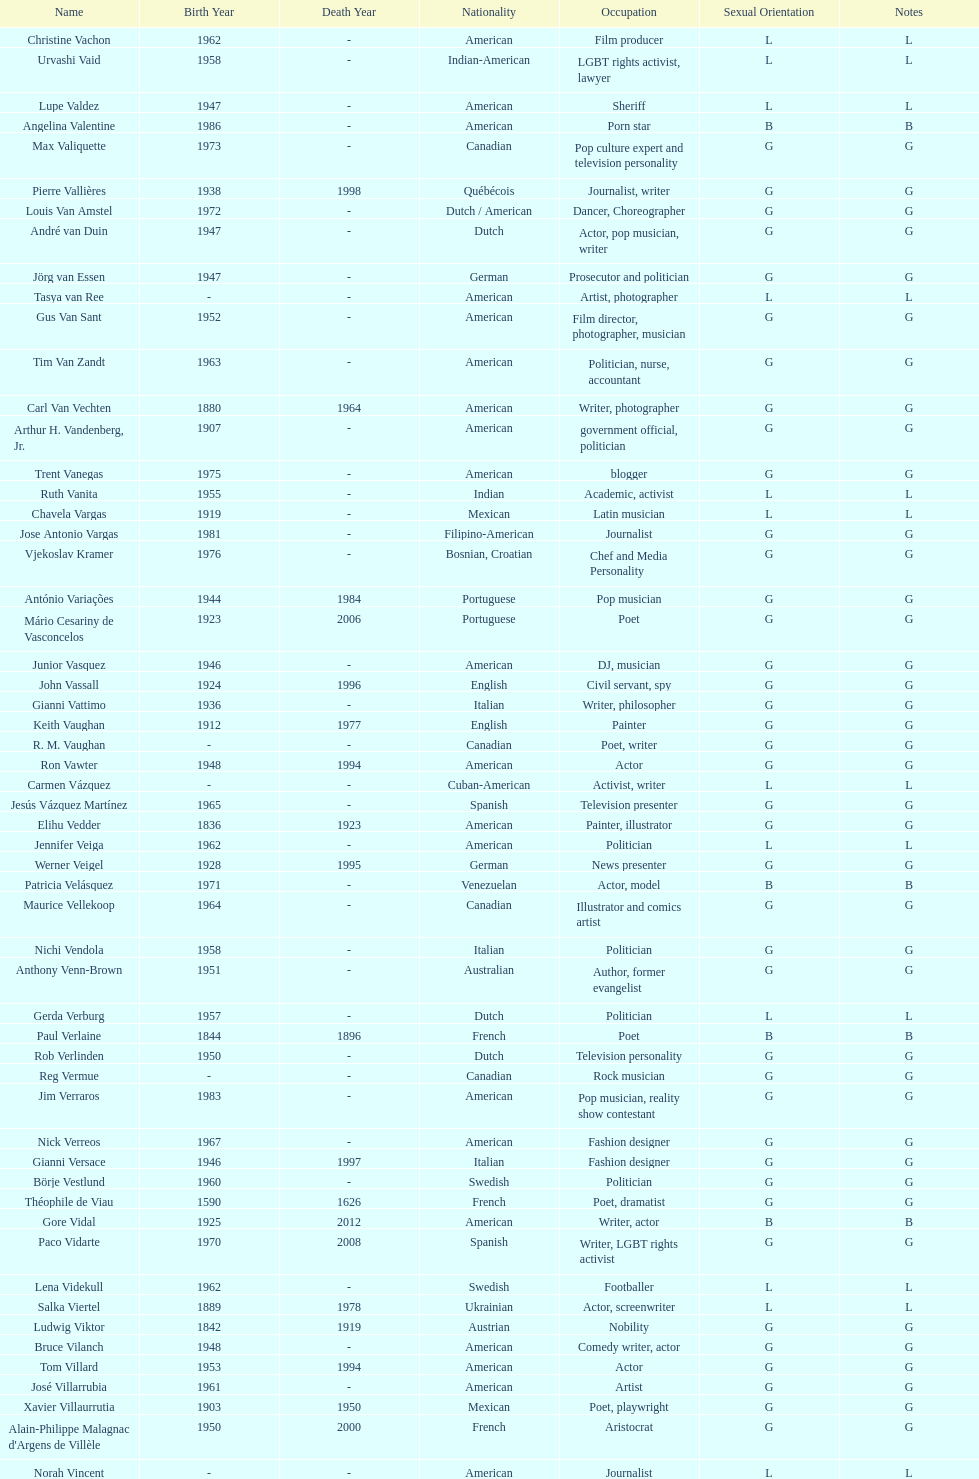Who lived longer, van vechten or variacoes? Van Vechten. Could you parse the entire table as a dict? {'header': ['Name', 'Birth Year', 'Death Year', 'Nationality', 'Occupation', 'Sexual Orientation', 'Notes'], 'rows': [['Christine Vachon', '1962', '-', 'American', 'Film producer', 'L', 'L'], ['Urvashi Vaid', '1958', '-', 'Indian-American', 'LGBT rights activist, lawyer', 'L', 'L'], ['Lupe Valdez', '1947', '-', 'American', 'Sheriff', 'L', 'L'], ['Angelina Valentine', '1986', '-', 'American', 'Porn star', 'B', 'B'], ['Max Valiquette', '1973', '-', 'Canadian', 'Pop culture expert and television personality', 'G', 'G'], ['Pierre Vallières', '1938', '1998', 'Québécois', 'Journalist, writer', 'G', 'G'], ['Louis Van Amstel', '1972', '-', 'Dutch / American', 'Dancer, Choreographer', 'G', 'G'], ['André van Duin', '1947', '-', 'Dutch', 'Actor, pop musician, writer', 'G', 'G'], ['Jörg van Essen', '1947', '-', 'German', 'Prosecutor and politician', 'G', 'G'], ['Tasya van Ree', '-', '-', 'American', 'Artist, photographer', 'L', 'L'], ['Gus Van Sant', '1952', '-', 'American', 'Film director, photographer, musician', 'G', 'G'], ['Tim Van Zandt', '1963', '-', 'American', 'Politician, nurse, accountant', 'G', 'G'], ['Carl Van Vechten', '1880', '1964', 'American', 'Writer, photographer', 'G', 'G'], ['Arthur H. Vandenberg, Jr.', '1907', '-', 'American', 'government official, politician', 'G', 'G'], ['Trent Vanegas', '1975', '-', 'American', 'blogger', 'G', 'G'], ['Ruth Vanita', '1955', '-', 'Indian', 'Academic, activist', 'L', 'L'], ['Chavela Vargas', '1919', '-', 'Mexican', 'Latin musician', 'L', 'L'], ['Jose Antonio Vargas', '1981', '-', 'Filipino-American', 'Journalist', 'G', 'G'], ['Vjekoslav Kramer', '1976', '-', 'Bosnian, Croatian', 'Chef and Media Personality', 'G', 'G'], ['António Variações', '1944', '1984', 'Portuguese', 'Pop musician', 'G', 'G'], ['Mário Cesariny de Vasconcelos', '1923', '2006', 'Portuguese', 'Poet', 'G', 'G'], ['Junior Vasquez', '1946', '-', 'American', 'DJ, musician', 'G', 'G'], ['John Vassall', '1924', '1996', 'English', 'Civil servant, spy', 'G', 'G'], ['Gianni Vattimo', '1936', '-', 'Italian', 'Writer, philosopher', 'G', 'G'], ['Keith Vaughan', '1912', '1977', 'English', 'Painter', 'G', 'G'], ['R. M. Vaughan', '-', '-', 'Canadian', 'Poet, writer', 'G', 'G'], ['Ron Vawter', '1948', '1994', 'American', 'Actor', 'G', 'G'], ['Carmen Vázquez', '-', '-', 'Cuban-American', 'Activist, writer', 'L', 'L'], ['Jesús Vázquez Martínez', '1965', '-', 'Spanish', 'Television presenter', 'G', 'G'], ['Elihu Vedder', '1836', '1923', 'American', 'Painter, illustrator', 'G', 'G'], ['Jennifer Veiga', '1962', '-', 'American', 'Politician', 'L', 'L'], ['Werner Veigel', '1928', '1995', 'German', 'News presenter', 'G', 'G'], ['Patricia Velásquez', '1971', '-', 'Venezuelan', 'Actor, model', 'B', 'B'], ['Maurice Vellekoop', '1964', '-', 'Canadian', 'Illustrator and comics artist', 'G', 'G'], ['Nichi Vendola', '1958', '-', 'Italian', 'Politician', 'G', 'G'], ['Anthony Venn-Brown', '1951', '-', 'Australian', 'Author, former evangelist', 'G', 'G'], ['Gerda Verburg', '1957', '-', 'Dutch', 'Politician', 'L', 'L'], ['Paul Verlaine', '1844', '1896', 'French', 'Poet', 'B', 'B'], ['Rob Verlinden', '1950', '-', 'Dutch', 'Television personality', 'G', 'G'], ['Reg Vermue', '-', '-', 'Canadian', 'Rock musician', 'G', 'G'], ['Jim Verraros', '1983', '-', 'American', 'Pop musician, reality show contestant', 'G', 'G'], ['Nick Verreos', '1967', '-', 'American', 'Fashion designer', 'G', 'G'], ['Gianni Versace', '1946', '1997', 'Italian', 'Fashion designer', 'G', 'G'], ['Börje Vestlund', '1960', '-', 'Swedish', 'Politician', 'G', 'G'], ['Théophile de Viau', '1590', '1626', 'French', 'Poet, dramatist', 'G', 'G'], ['Gore Vidal', '1925', '2012', 'American', 'Writer, actor', 'B', 'B'], ['Paco Vidarte', '1970', '2008', 'Spanish', 'Writer, LGBT rights activist', 'G', 'G'], ['Lena Videkull', '1962', '-', 'Swedish', 'Footballer', 'L', 'L'], ['Salka Viertel', '1889', '1978', 'Ukrainian', 'Actor, screenwriter', 'L', 'L'], ['Ludwig Viktor', '1842', '1919', 'Austrian', 'Nobility', 'G', 'G'], ['Bruce Vilanch', '1948', '-', 'American', 'Comedy writer, actor', 'G', 'G'], ['Tom Villard', '1953', '1994', 'American', 'Actor', 'G', 'G'], ['José Villarrubia', '1961', '-', 'American', 'Artist', 'G', 'G'], ['Xavier Villaurrutia', '1903', '1950', 'Mexican', 'Poet, playwright', 'G', 'G'], ["Alain-Philippe Malagnac d'Argens de Villèle", '1950', '2000', 'French', 'Aristocrat', 'G', 'G'], ['Norah Vincent', '-', '-', 'American', 'Journalist', 'L', 'L'], ['Donald Vining', '1917', '1998', 'American', 'Writer', 'G', 'G'], ['Luchino Visconti', '1906', '1976', 'Italian', 'Filmmaker', 'G', 'G'], ['Pavel Vítek', '1962', '-', 'Czech', 'Pop musician, actor', 'G', 'G'], ['Renée Vivien', '1877', '1909', 'English', 'Poet', 'L', 'L'], ['Claude Vivier', '1948', '1983', 'Canadian', '20th century classical composer', 'G', 'G'], ['Taylor Vixen', '1983', '-', 'American', 'Porn star', 'B', 'B'], ['Bruce Voeller', '1934', '1994', 'American', 'HIV/AIDS researcher', 'G', 'G'], ['Paula Vogel', '1951', '-', 'American', 'Playwright', 'L', 'L'], ['Julia Volkova', '1985', '-', 'Russian', 'Singer', 'B', 'B'], ['Jörg van Essen', '1947', '-', 'German', 'Politician', 'G', 'G'], ['Ole von Beust', '1955', '-', 'German', 'Politician', 'G', 'G'], ['Wilhelm von Gloeden', '1856', '1931', 'German', 'Photographer', 'G', 'G'], ['Rosa von Praunheim', '1942', '-', 'German', 'Film director', 'G', 'G'], ['Kurt von Ruffin', '1901', '1996', 'German', 'Holocaust survivor', 'G', 'G'], ['Hella von Sinnen', '1959', '-', 'German', 'Comedian', 'L', 'L'], ['Daniel Vosovic', '1981', '-', 'American', 'Fashion designer', 'G', 'G'], ['Delwin Vriend', '1966', '-', 'Canadian', 'LGBT rights activist', 'G', 'G']]} 